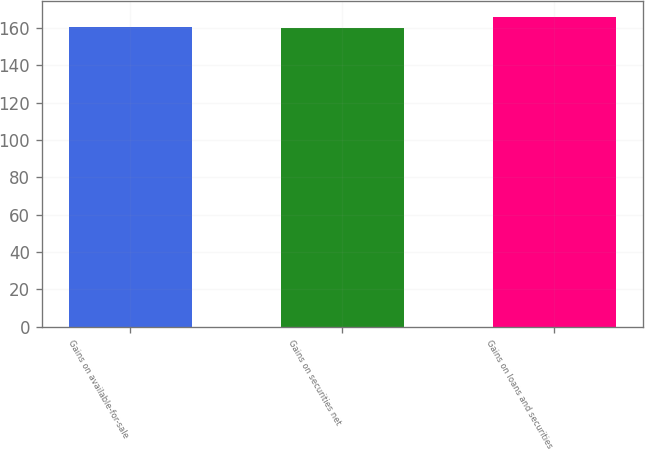Convert chart to OTSL. <chart><loc_0><loc_0><loc_500><loc_500><bar_chart><fcel>Gains on available-for-sale<fcel>Gains on securities net<fcel>Gains on loans and securities<nl><fcel>160.7<fcel>159.9<fcel>166.2<nl></chart> 